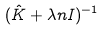Convert formula to latex. <formula><loc_0><loc_0><loc_500><loc_500>( \hat { K } + \lambda n I ) ^ { - 1 }</formula> 